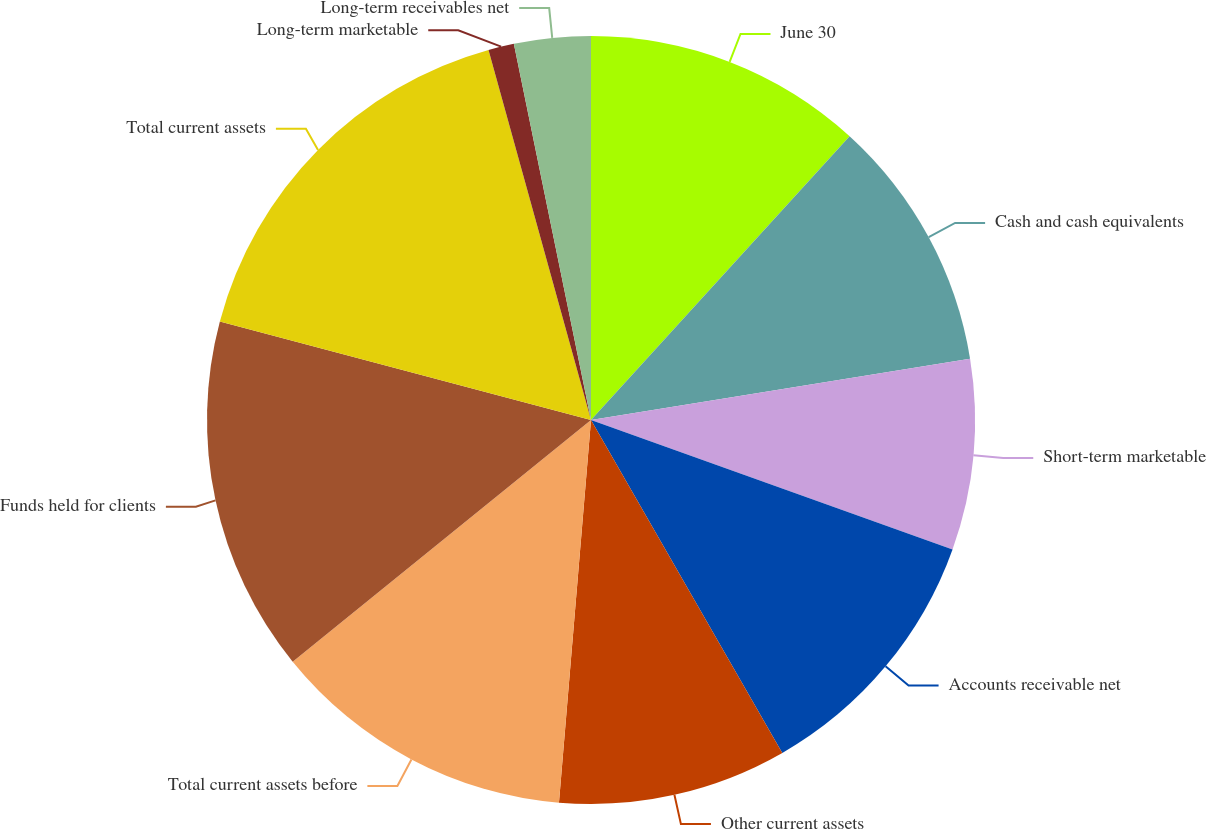Convert chart. <chart><loc_0><loc_0><loc_500><loc_500><pie_chart><fcel>June 30<fcel>Cash and cash equivalents<fcel>Short-term marketable<fcel>Accounts receivable net<fcel>Other current assets<fcel>Total current assets before<fcel>Funds held for clients<fcel>Total current assets<fcel>Long-term marketable<fcel>Long-term receivables net<nl><fcel>11.76%<fcel>10.69%<fcel>8.02%<fcel>11.23%<fcel>9.63%<fcel>12.83%<fcel>14.97%<fcel>16.57%<fcel>1.08%<fcel>3.22%<nl></chart> 